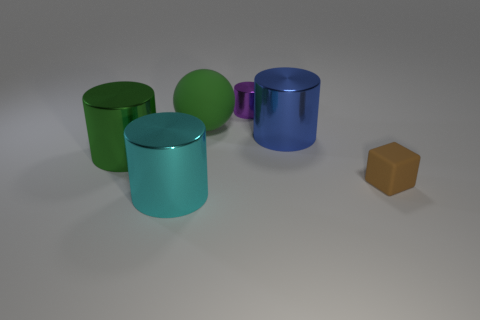The objects seem to have different textures; can you describe them? Yes, the objects exhibit two main types of texture. The four cylinders have a glossy, reflective surface that interacts dynamically with the light source, causing highlights and slight distortions of the surrounding colors on their surfaces. In contrast, the cube has a matte finish that diffuses the light more evenly, resulting in a solid, uniform color without reflections. 